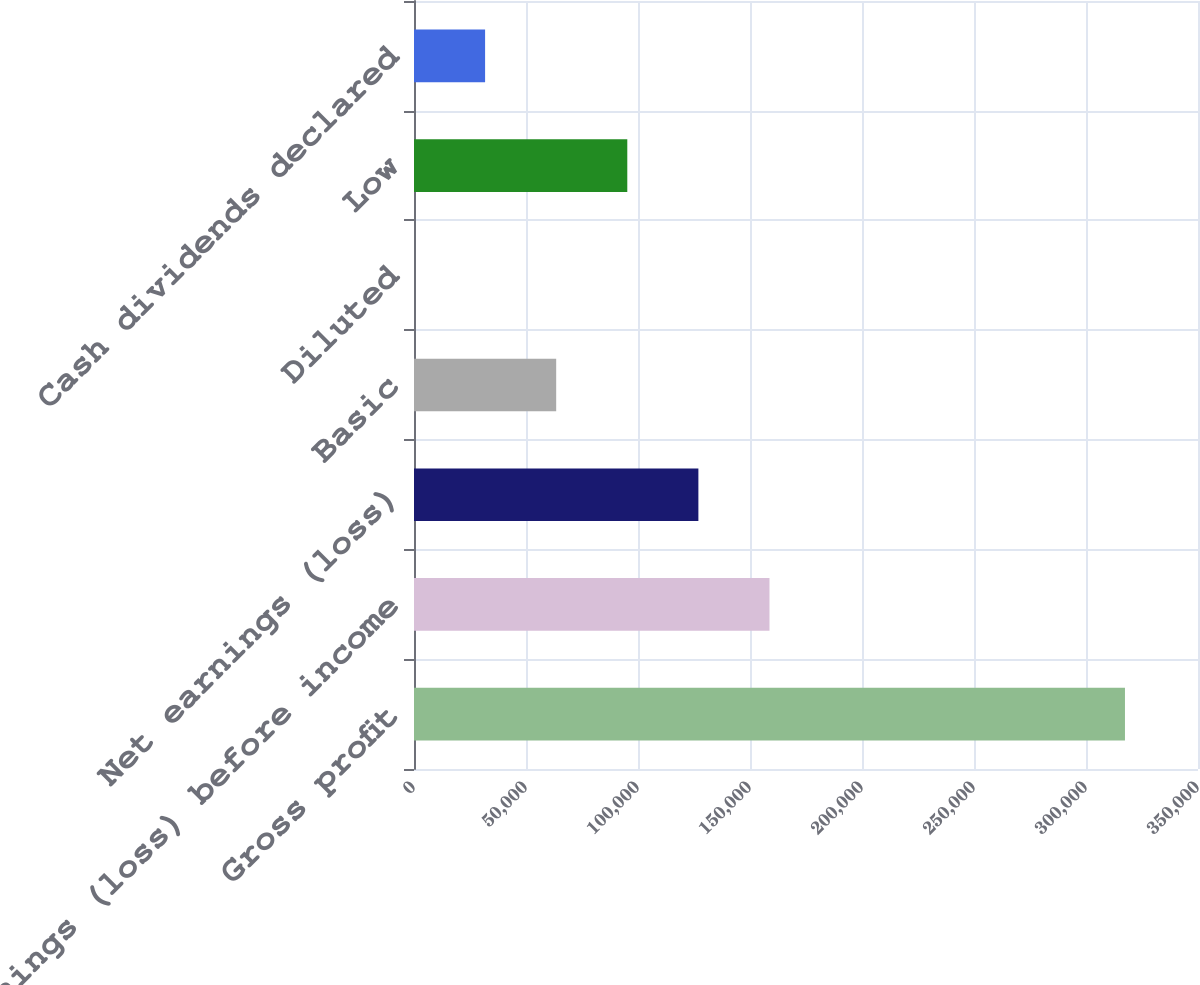Convert chart to OTSL. <chart><loc_0><loc_0><loc_500><loc_500><bar_chart><fcel>Gross profit<fcel>Earnings (loss) before income<fcel>Net earnings (loss)<fcel>Basic<fcel>Diluted<fcel>Low<fcel>Cash dividends declared<nl><fcel>317395<fcel>158698<fcel>126958<fcel>63479.1<fcel>0.07<fcel>95218.5<fcel>31739.6<nl></chart> 